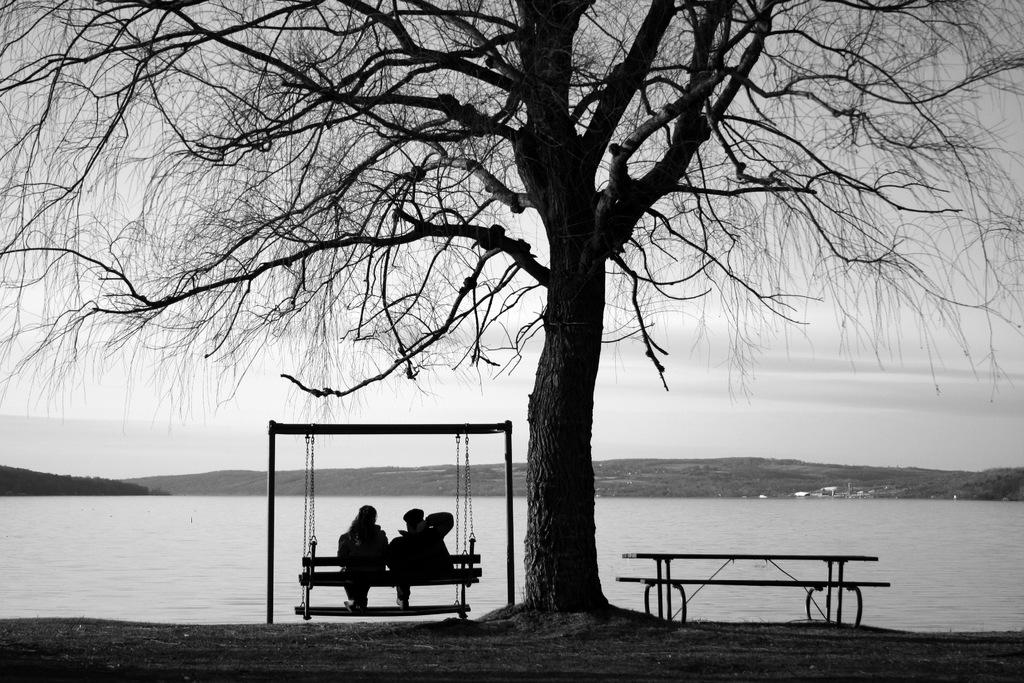How many people are on the swing in the image? There are two persons sitting on a swing in the image. What can be seen in the image besides the swing? There is a dried tree and water visible in the background. What is the color of the sky in the image? The sky appears to be white in color. How many kittens are playing with a bead in the image? There are no kittens or beads present in the image. 